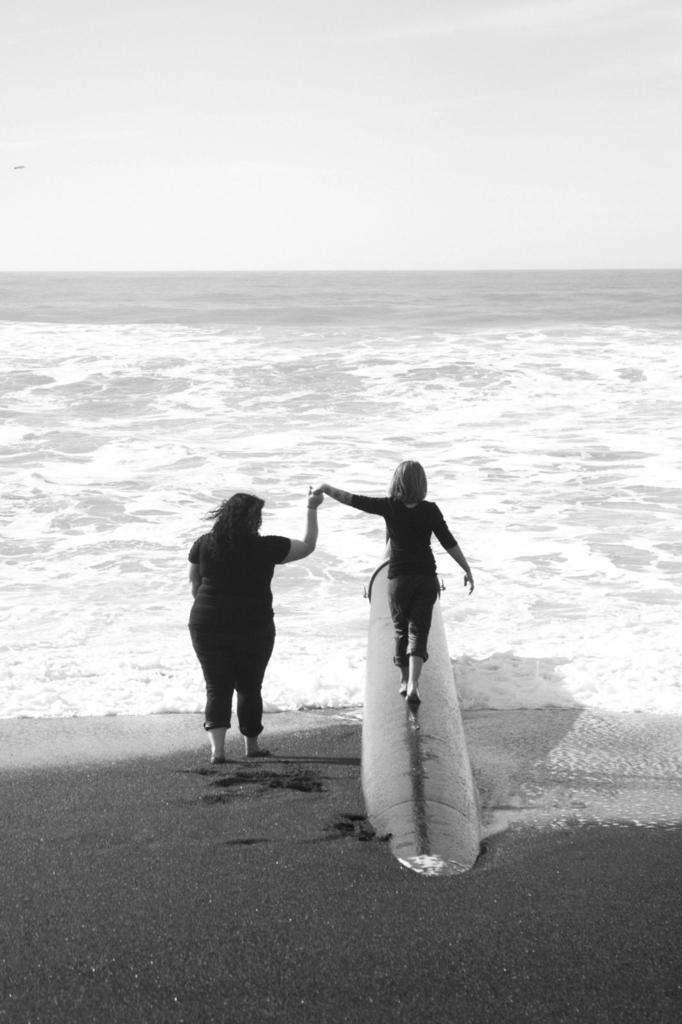Can you describe this image briefly? In this image I can see a woman and a girl. In the background I can see water and the sky. The girl is standing on an object. This image is black and white in color. 